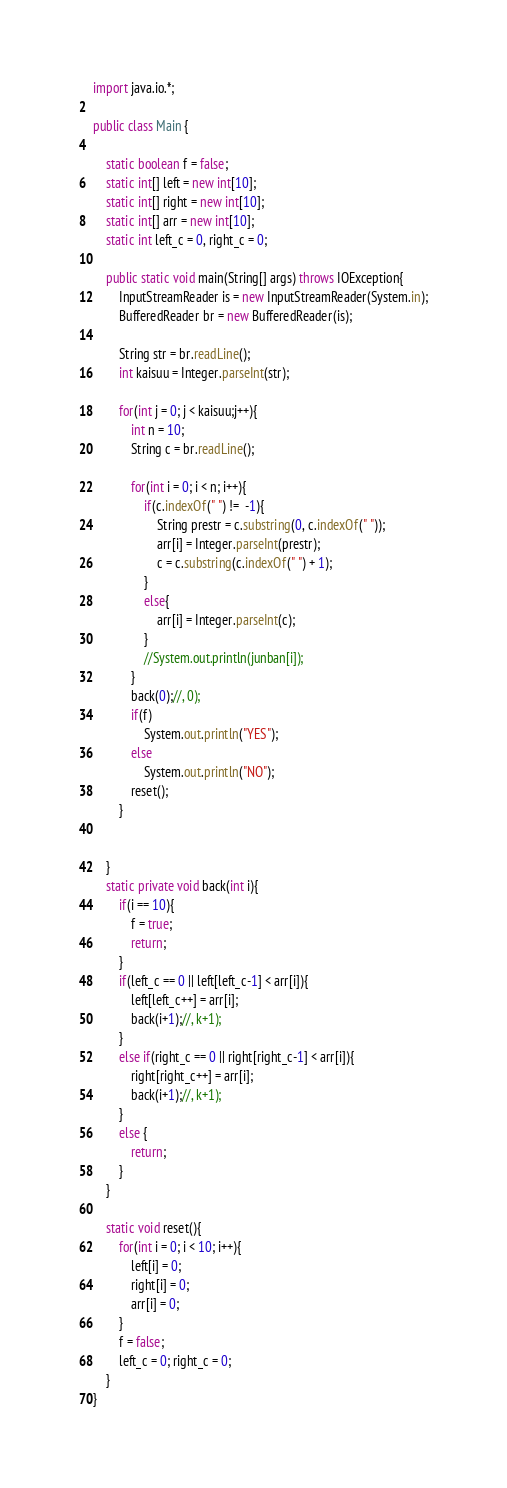Convert code to text. <code><loc_0><loc_0><loc_500><loc_500><_Java_>import java.io.*;

public class Main {

	static boolean f = false;
	static int[] left = new int[10];
	static int[] right = new int[10];
	static int[] arr = new int[10];
	static int left_c = 0, right_c = 0;
	
	public static void main(String[] args) throws IOException{
		InputStreamReader is = new InputStreamReader(System.in);
		BufferedReader br = new BufferedReader(is);

		String str = br.readLine();
		int kaisuu = Integer.parseInt(str);

		for(int j = 0; j < kaisuu;j++){
			int n = 10;
			String c = br.readLine();

			for(int i = 0; i < n; i++){
				if(c.indexOf(" ") !=  -1){
					String prestr = c.substring(0, c.indexOf(" "));
					arr[i] = Integer.parseInt(prestr);
					c = c.substring(c.indexOf(" ") + 1);
				}
				else{
					arr[i] = Integer.parseInt(c);
				}
				//System.out.println(junban[i]);
			}
			back(0);//, 0);
			if(f)
				System.out.println("YES");
			else
				System.out.println("NO");
			reset();
		}
		
		
	}
	static private void back(int i){
		if(i == 10){
			f = true;
			return;
		}
		if(left_c == 0 || left[left_c-1] < arr[i]){
			left[left_c++] = arr[i];
			back(i+1);//, k+1);
		}
		else if(right_c == 0 || right[right_c-1] < arr[i]){
			right[right_c++] = arr[i];
			back(i+1);//, k+1);
		}
		else {
			return;
		}
	}
	
	static void reset(){
		for(int i = 0; i < 10; i++){
			left[i] = 0;
			right[i] = 0;
			arr[i] = 0;
		}
		f = false;
		left_c = 0; right_c = 0;
	}
}</code> 